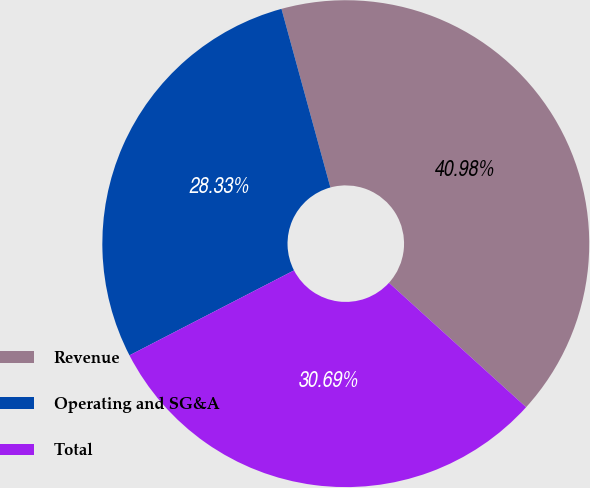Convert chart. <chart><loc_0><loc_0><loc_500><loc_500><pie_chart><fcel>Revenue<fcel>Operating and SG&A<fcel>Total<nl><fcel>40.98%<fcel>28.33%<fcel>30.69%<nl></chart> 